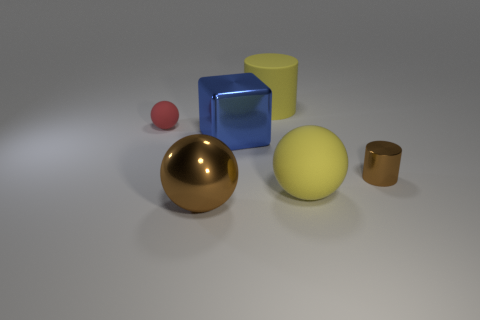Add 4 blue metal cubes. How many objects exist? 10 Subtract all blocks. How many objects are left? 5 Add 4 large matte objects. How many large matte objects are left? 6 Add 6 cyan rubber cubes. How many cyan rubber cubes exist? 6 Subtract 0 red cylinders. How many objects are left? 6 Subtract all big metallic balls. Subtract all tiny red matte things. How many objects are left? 4 